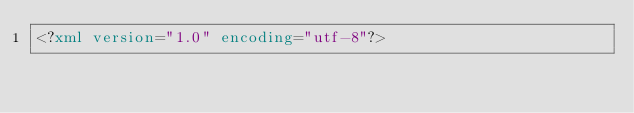<code> <loc_0><loc_0><loc_500><loc_500><_XML_><?xml version="1.0" encoding="utf-8"?></code> 